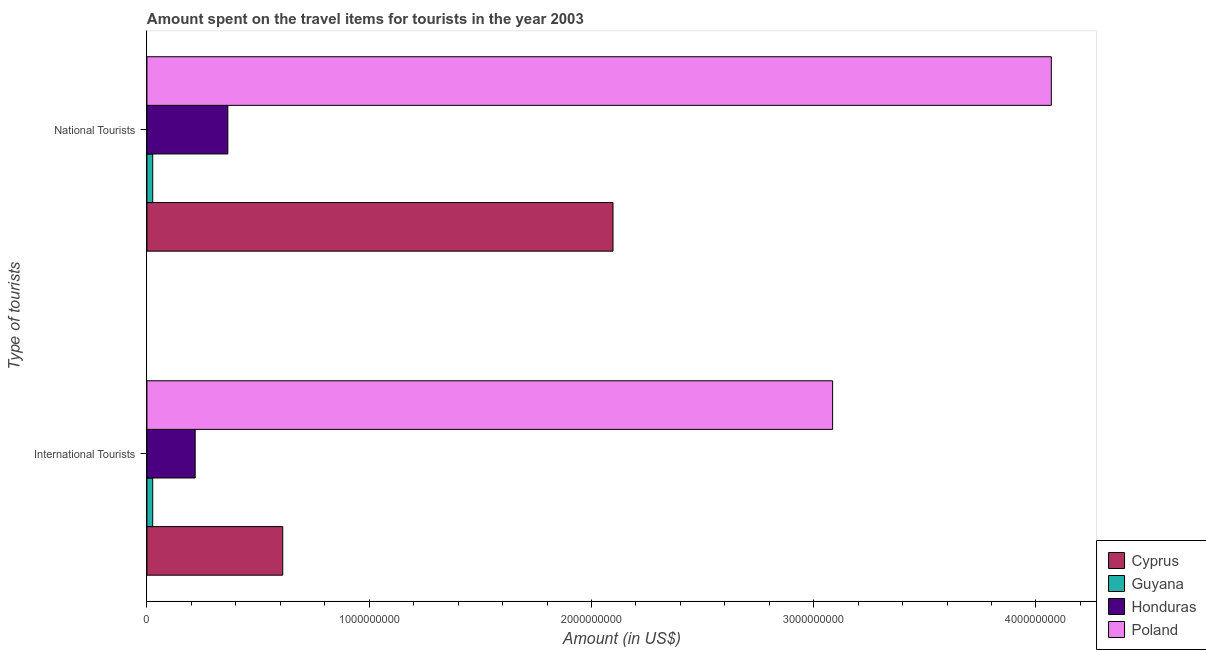How many different coloured bars are there?
Provide a succinct answer. 4. Are the number of bars per tick equal to the number of legend labels?
Provide a succinct answer. Yes. How many bars are there on the 2nd tick from the top?
Give a very brief answer. 4. How many bars are there on the 2nd tick from the bottom?
Offer a very short reply. 4. What is the label of the 1st group of bars from the top?
Provide a short and direct response. National Tourists. What is the amount spent on travel items of national tourists in Honduras?
Provide a succinct answer. 3.64e+08. Across all countries, what is the maximum amount spent on travel items of national tourists?
Ensure brevity in your answer.  4.07e+09. Across all countries, what is the minimum amount spent on travel items of national tourists?
Give a very brief answer. 2.60e+07. In which country was the amount spent on travel items of national tourists minimum?
Ensure brevity in your answer.  Guyana. What is the total amount spent on travel items of international tourists in the graph?
Make the answer very short. 3.94e+09. What is the difference between the amount spent on travel items of international tourists in Cyprus and that in Honduras?
Keep it short and to the point. 3.94e+08. What is the difference between the amount spent on travel items of international tourists in Honduras and the amount spent on travel items of national tourists in Cyprus?
Your answer should be very brief. -1.88e+09. What is the average amount spent on travel items of international tourists per country?
Offer a very short reply. 9.85e+08. What is the difference between the amount spent on travel items of national tourists and amount spent on travel items of international tourists in Poland?
Offer a terse response. 9.84e+08. Is the amount spent on travel items of international tourists in Guyana less than that in Honduras?
Give a very brief answer. Yes. In how many countries, is the amount spent on travel items of national tourists greater than the average amount spent on travel items of national tourists taken over all countries?
Offer a very short reply. 2. What does the 1st bar from the top in International Tourists represents?
Provide a short and direct response. Poland. What does the 2nd bar from the bottom in International Tourists represents?
Provide a short and direct response. Guyana. How many bars are there?
Keep it short and to the point. 8. Are all the bars in the graph horizontal?
Provide a succinct answer. Yes. How many countries are there in the graph?
Your response must be concise. 4. What is the difference between two consecutive major ticks on the X-axis?
Offer a very short reply. 1.00e+09. Where does the legend appear in the graph?
Provide a short and direct response. Bottom right. How many legend labels are there?
Provide a short and direct response. 4. How are the legend labels stacked?
Your answer should be very brief. Vertical. What is the title of the graph?
Provide a short and direct response. Amount spent on the travel items for tourists in the year 2003. Does "Tanzania" appear as one of the legend labels in the graph?
Ensure brevity in your answer.  No. What is the label or title of the Y-axis?
Provide a short and direct response. Type of tourists. What is the Amount (in US$) of Cyprus in International Tourists?
Ensure brevity in your answer.  6.11e+08. What is the Amount (in US$) in Guyana in International Tourists?
Your response must be concise. 2.60e+07. What is the Amount (in US$) in Honduras in International Tourists?
Your answer should be very brief. 2.17e+08. What is the Amount (in US$) of Poland in International Tourists?
Offer a very short reply. 3.08e+09. What is the Amount (in US$) in Cyprus in National Tourists?
Provide a succinct answer. 2.10e+09. What is the Amount (in US$) of Guyana in National Tourists?
Provide a succinct answer. 2.60e+07. What is the Amount (in US$) in Honduras in National Tourists?
Your response must be concise. 3.64e+08. What is the Amount (in US$) in Poland in National Tourists?
Make the answer very short. 4.07e+09. Across all Type of tourists, what is the maximum Amount (in US$) of Cyprus?
Your response must be concise. 2.10e+09. Across all Type of tourists, what is the maximum Amount (in US$) of Guyana?
Your answer should be very brief. 2.60e+07. Across all Type of tourists, what is the maximum Amount (in US$) in Honduras?
Give a very brief answer. 3.64e+08. Across all Type of tourists, what is the maximum Amount (in US$) of Poland?
Offer a very short reply. 4.07e+09. Across all Type of tourists, what is the minimum Amount (in US$) of Cyprus?
Keep it short and to the point. 6.11e+08. Across all Type of tourists, what is the minimum Amount (in US$) of Guyana?
Offer a very short reply. 2.60e+07. Across all Type of tourists, what is the minimum Amount (in US$) in Honduras?
Offer a very short reply. 2.17e+08. Across all Type of tourists, what is the minimum Amount (in US$) in Poland?
Provide a short and direct response. 3.08e+09. What is the total Amount (in US$) in Cyprus in the graph?
Provide a succinct answer. 2.71e+09. What is the total Amount (in US$) of Guyana in the graph?
Your response must be concise. 5.20e+07. What is the total Amount (in US$) of Honduras in the graph?
Your answer should be compact. 5.81e+08. What is the total Amount (in US$) in Poland in the graph?
Keep it short and to the point. 7.15e+09. What is the difference between the Amount (in US$) in Cyprus in International Tourists and that in National Tourists?
Provide a succinct answer. -1.49e+09. What is the difference between the Amount (in US$) in Guyana in International Tourists and that in National Tourists?
Keep it short and to the point. 0. What is the difference between the Amount (in US$) of Honduras in International Tourists and that in National Tourists?
Provide a short and direct response. -1.47e+08. What is the difference between the Amount (in US$) of Poland in International Tourists and that in National Tourists?
Offer a very short reply. -9.84e+08. What is the difference between the Amount (in US$) in Cyprus in International Tourists and the Amount (in US$) in Guyana in National Tourists?
Give a very brief answer. 5.85e+08. What is the difference between the Amount (in US$) of Cyprus in International Tourists and the Amount (in US$) of Honduras in National Tourists?
Give a very brief answer. 2.47e+08. What is the difference between the Amount (in US$) in Cyprus in International Tourists and the Amount (in US$) in Poland in National Tourists?
Your answer should be very brief. -3.46e+09. What is the difference between the Amount (in US$) of Guyana in International Tourists and the Amount (in US$) of Honduras in National Tourists?
Make the answer very short. -3.38e+08. What is the difference between the Amount (in US$) in Guyana in International Tourists and the Amount (in US$) in Poland in National Tourists?
Give a very brief answer. -4.04e+09. What is the difference between the Amount (in US$) of Honduras in International Tourists and the Amount (in US$) of Poland in National Tourists?
Provide a short and direct response. -3.85e+09. What is the average Amount (in US$) of Cyprus per Type of tourists?
Give a very brief answer. 1.35e+09. What is the average Amount (in US$) in Guyana per Type of tourists?
Provide a succinct answer. 2.60e+07. What is the average Amount (in US$) in Honduras per Type of tourists?
Your response must be concise. 2.90e+08. What is the average Amount (in US$) of Poland per Type of tourists?
Make the answer very short. 3.58e+09. What is the difference between the Amount (in US$) of Cyprus and Amount (in US$) of Guyana in International Tourists?
Your answer should be compact. 5.85e+08. What is the difference between the Amount (in US$) in Cyprus and Amount (in US$) in Honduras in International Tourists?
Keep it short and to the point. 3.94e+08. What is the difference between the Amount (in US$) of Cyprus and Amount (in US$) of Poland in International Tourists?
Your response must be concise. -2.47e+09. What is the difference between the Amount (in US$) in Guyana and Amount (in US$) in Honduras in International Tourists?
Keep it short and to the point. -1.91e+08. What is the difference between the Amount (in US$) in Guyana and Amount (in US$) in Poland in International Tourists?
Offer a terse response. -3.06e+09. What is the difference between the Amount (in US$) of Honduras and Amount (in US$) of Poland in International Tourists?
Keep it short and to the point. -2.87e+09. What is the difference between the Amount (in US$) in Cyprus and Amount (in US$) in Guyana in National Tourists?
Your response must be concise. 2.07e+09. What is the difference between the Amount (in US$) of Cyprus and Amount (in US$) of Honduras in National Tourists?
Make the answer very short. 1.73e+09. What is the difference between the Amount (in US$) of Cyprus and Amount (in US$) of Poland in National Tourists?
Ensure brevity in your answer.  -1.97e+09. What is the difference between the Amount (in US$) of Guyana and Amount (in US$) of Honduras in National Tourists?
Ensure brevity in your answer.  -3.38e+08. What is the difference between the Amount (in US$) of Guyana and Amount (in US$) of Poland in National Tourists?
Make the answer very short. -4.04e+09. What is the difference between the Amount (in US$) in Honduras and Amount (in US$) in Poland in National Tourists?
Your response must be concise. -3.70e+09. What is the ratio of the Amount (in US$) of Cyprus in International Tourists to that in National Tourists?
Provide a short and direct response. 0.29. What is the ratio of the Amount (in US$) of Guyana in International Tourists to that in National Tourists?
Your response must be concise. 1. What is the ratio of the Amount (in US$) of Honduras in International Tourists to that in National Tourists?
Your response must be concise. 0.6. What is the ratio of the Amount (in US$) in Poland in International Tourists to that in National Tourists?
Your answer should be very brief. 0.76. What is the difference between the highest and the second highest Amount (in US$) of Cyprus?
Your answer should be very brief. 1.49e+09. What is the difference between the highest and the second highest Amount (in US$) of Honduras?
Your answer should be very brief. 1.47e+08. What is the difference between the highest and the second highest Amount (in US$) in Poland?
Give a very brief answer. 9.84e+08. What is the difference between the highest and the lowest Amount (in US$) in Cyprus?
Keep it short and to the point. 1.49e+09. What is the difference between the highest and the lowest Amount (in US$) in Honduras?
Your answer should be very brief. 1.47e+08. What is the difference between the highest and the lowest Amount (in US$) in Poland?
Give a very brief answer. 9.84e+08. 